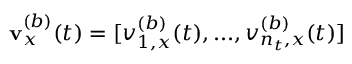<formula> <loc_0><loc_0><loc_500><loc_500>\mathbf v _ { x } ^ { ( b ) } ( t ) = [ v _ { 1 , x } ^ { ( b ) } ( t ) , \dots , v _ { n _ { t } , x } ^ { ( b ) } ( t ) ]</formula> 